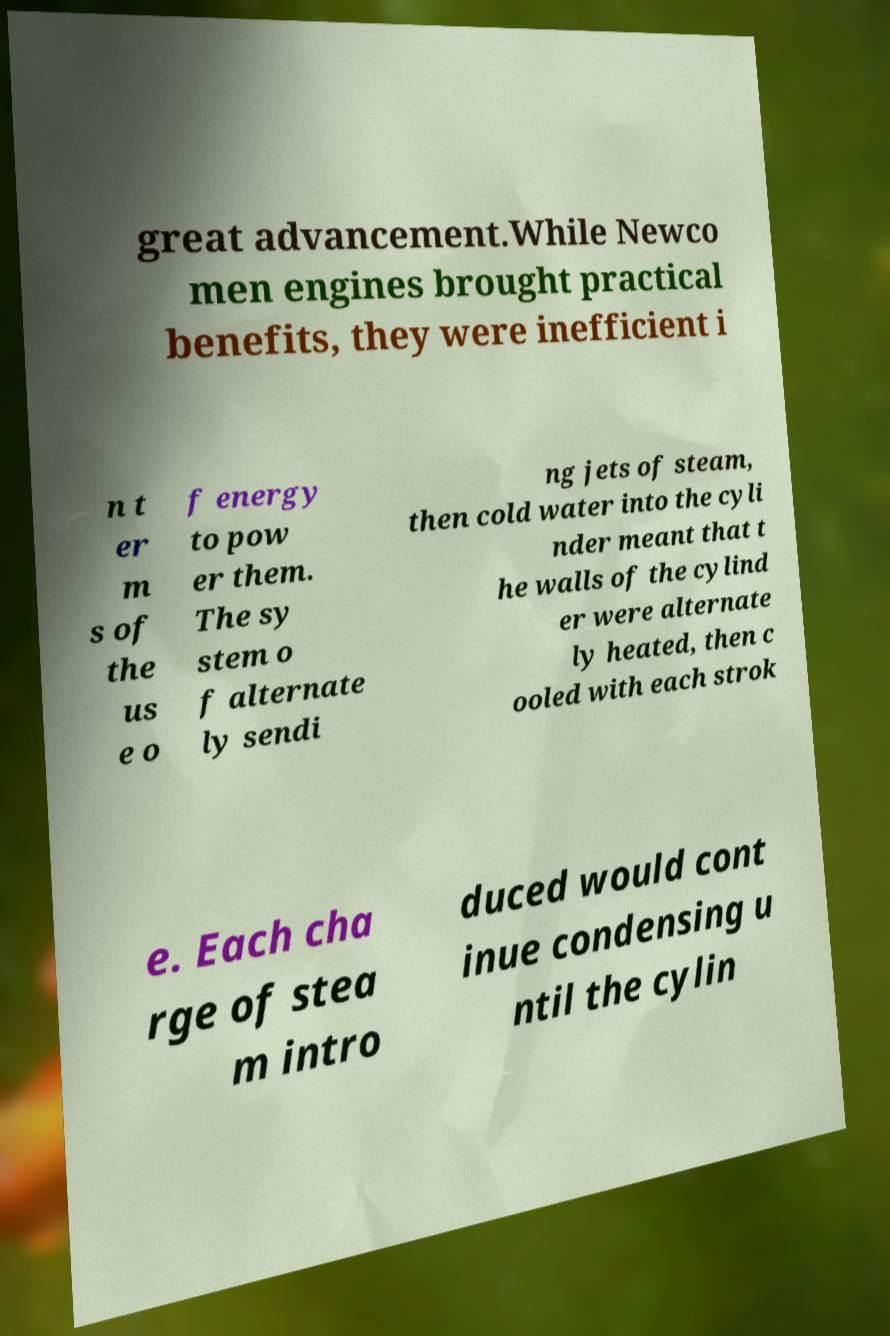Could you extract and type out the text from this image? great advancement.While Newco men engines brought practical benefits, they were inefficient i n t er m s of the us e o f energy to pow er them. The sy stem o f alternate ly sendi ng jets of steam, then cold water into the cyli nder meant that t he walls of the cylind er were alternate ly heated, then c ooled with each strok e. Each cha rge of stea m intro duced would cont inue condensing u ntil the cylin 